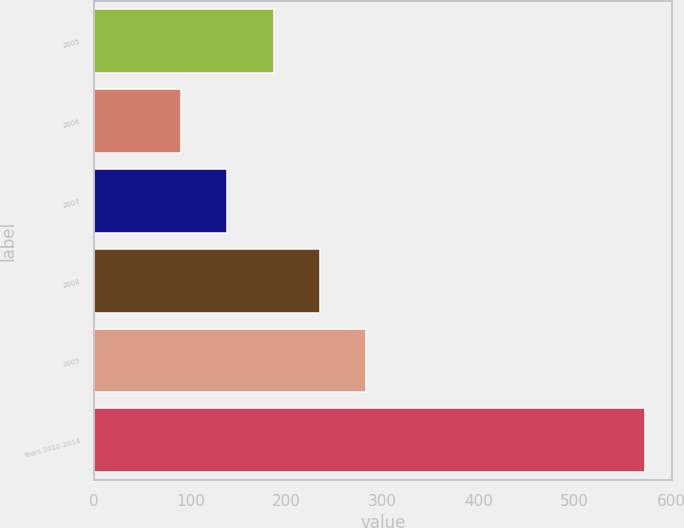<chart> <loc_0><loc_0><loc_500><loc_500><bar_chart><fcel>2005<fcel>2006<fcel>2007<fcel>2008<fcel>2009<fcel>Years 2010-2014<nl><fcel>186.6<fcel>90<fcel>138.3<fcel>234.9<fcel>283.2<fcel>573<nl></chart> 